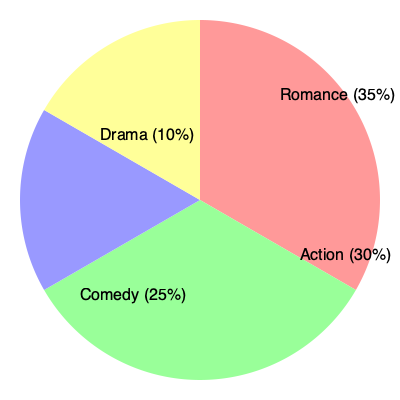Based on the pie chart depicting the genre distribution of Bollywood films in the last decade, what percentage of films fall under the combined categories of Romance and Comedy, and how does this compare to the percentage of Action films? To answer this question, we need to follow these steps:

1. Identify the percentages for Romance and Comedy:
   - Romance: 35%
   - Comedy: 25%

2. Calculate the combined percentage of Romance and Comedy:
   $35\% + 25\% = 60\%$

3. Identify the percentage for Action films:
   - Action: 30%

4. Compare the combined Romance and Comedy percentage to Action:
   The combined percentage of Romance and Comedy (60%) is double the percentage of Action films (30%).

5. Calculate the difference:
   $60\% - 30\% = 30\%$

Therefore, the combined categories of Romance and Comedy represent 60% of Bollywood films in the last decade, which is 30 percentage points higher than the Action genre at 30%.
Answer: 60%; 30 percentage points higher 